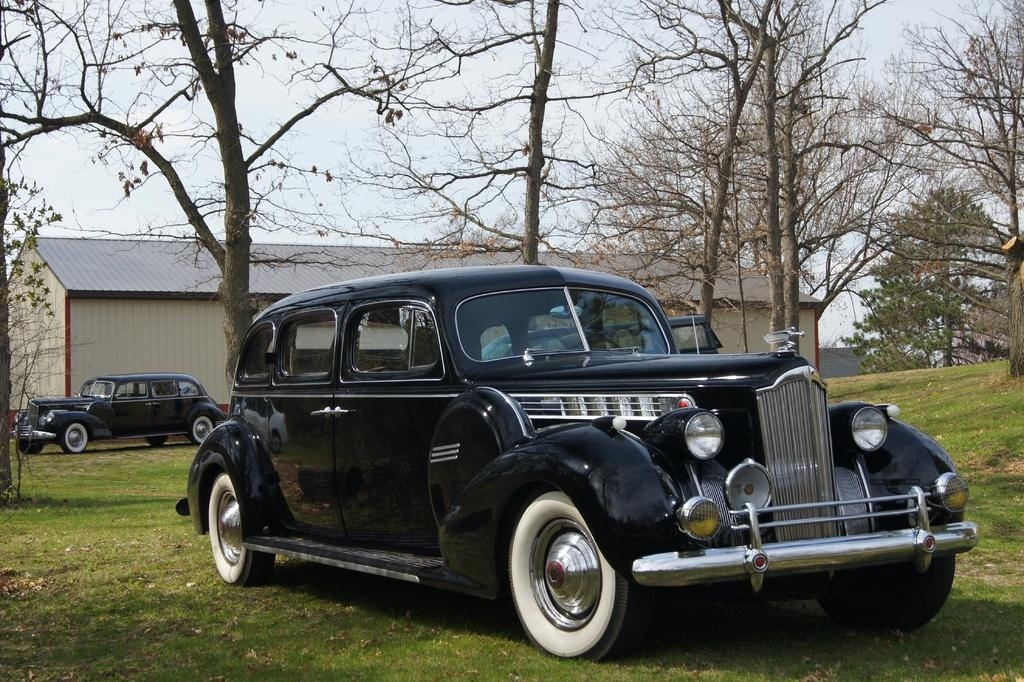What types of objects are present in the image? There are vehicles in the image. What type of natural environment is visible in the image? There is grass and trees in the image. What type of structure can be seen in the image? There is a shed in the image. What is visible in the background of the image? The sky is visible in the background of the image. Can you tell me how many snakes are slithering through the grass in the image? There are no snakes present in the image; it features vehicles, grass, trees, a shed, and the sky. What type of string is being used to tie the vehicles together in the image? There is no string or any indication of vehicles being tied together in the image. 